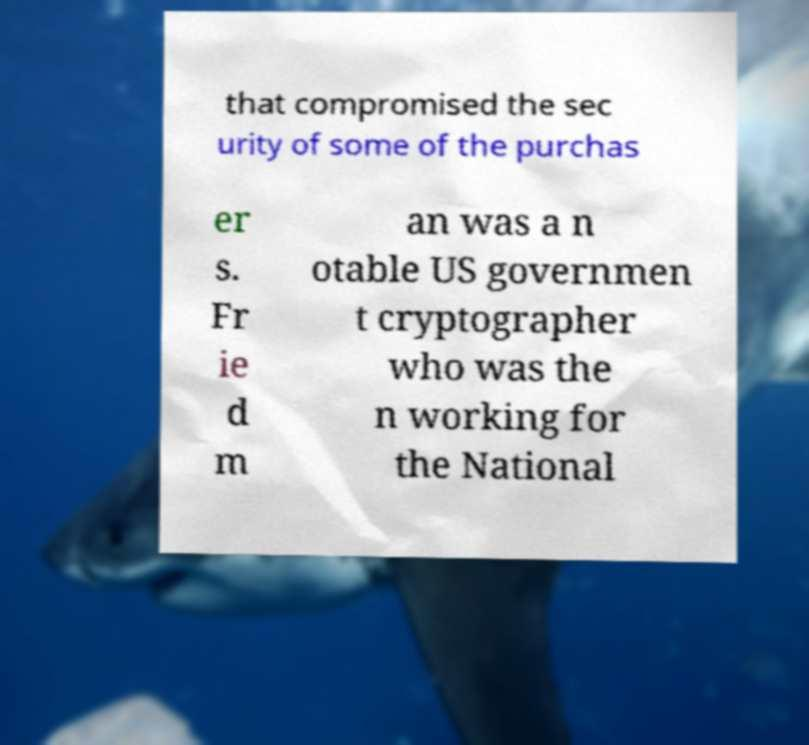Could you assist in decoding the text presented in this image and type it out clearly? that compromised the sec urity of some of the purchas er s. Fr ie d m an was a n otable US governmen t cryptographer who was the n working for the National 